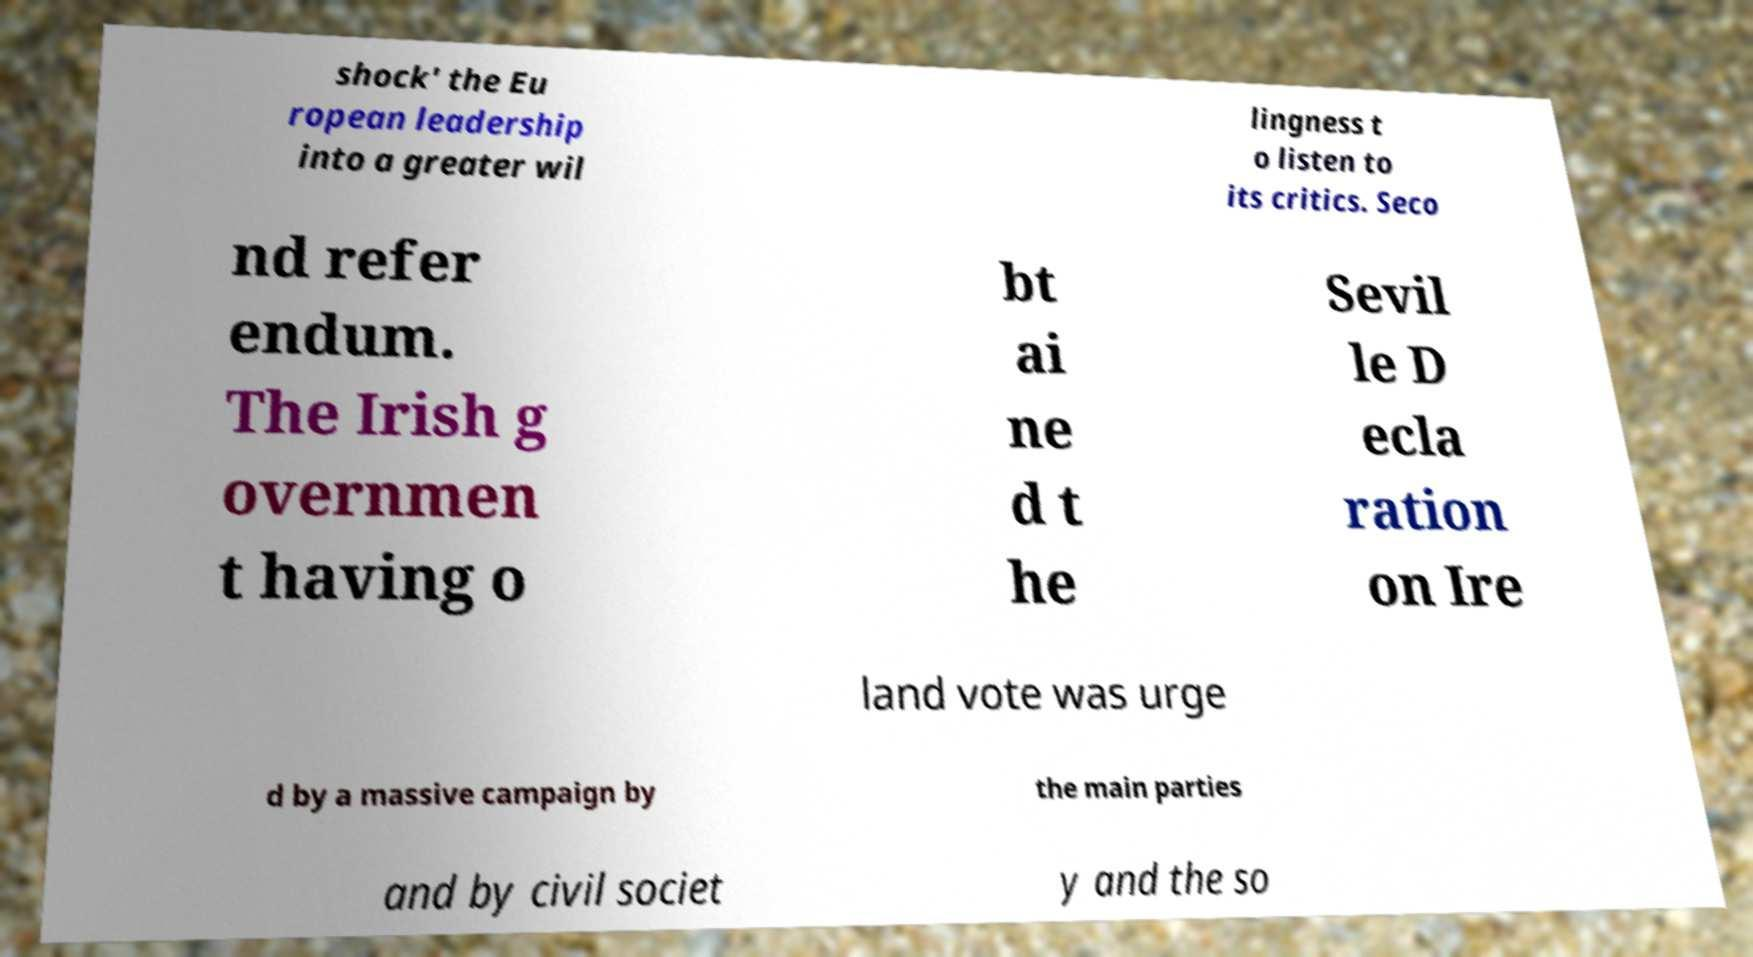Please read and relay the text visible in this image. What does it say? shock' the Eu ropean leadership into a greater wil lingness t o listen to its critics. Seco nd refer endum. The Irish g overnmen t having o bt ai ne d t he Sevil le D ecla ration on Ire land vote was urge d by a massive campaign by the main parties and by civil societ y and the so 